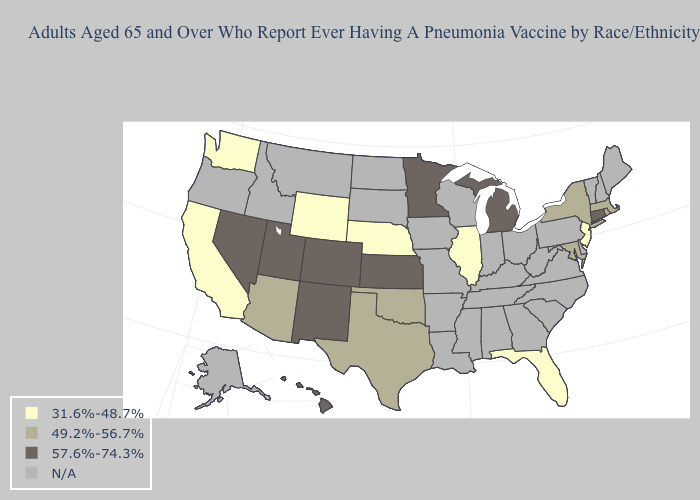Among the states that border Delaware , which have the lowest value?
Be succinct. New Jersey. What is the highest value in the MidWest ?
Short answer required. 57.6%-74.3%. Name the states that have a value in the range N/A?
Quick response, please. Alabama, Alaska, Arkansas, Delaware, Georgia, Idaho, Indiana, Iowa, Kentucky, Louisiana, Maine, Mississippi, Missouri, Montana, New Hampshire, North Carolina, North Dakota, Ohio, Oregon, Pennsylvania, South Carolina, South Dakota, Tennessee, Vermont, Virginia, West Virginia, Wisconsin. What is the value of North Dakota?
Answer briefly. N/A. Does Colorado have the highest value in the USA?
Write a very short answer. Yes. What is the value of Nebraska?
Answer briefly. 31.6%-48.7%. Does Kansas have the highest value in the USA?
Keep it brief. Yes. What is the value of Kentucky?
Keep it brief. N/A. What is the lowest value in the South?
Be succinct. 31.6%-48.7%. Does Washington have the highest value in the West?
Quick response, please. No. Name the states that have a value in the range 31.6%-48.7%?
Be succinct. California, Florida, Illinois, Nebraska, New Jersey, Washington, Wyoming. Does the map have missing data?
Concise answer only. Yes. What is the highest value in the South ?
Write a very short answer. 49.2%-56.7%. 